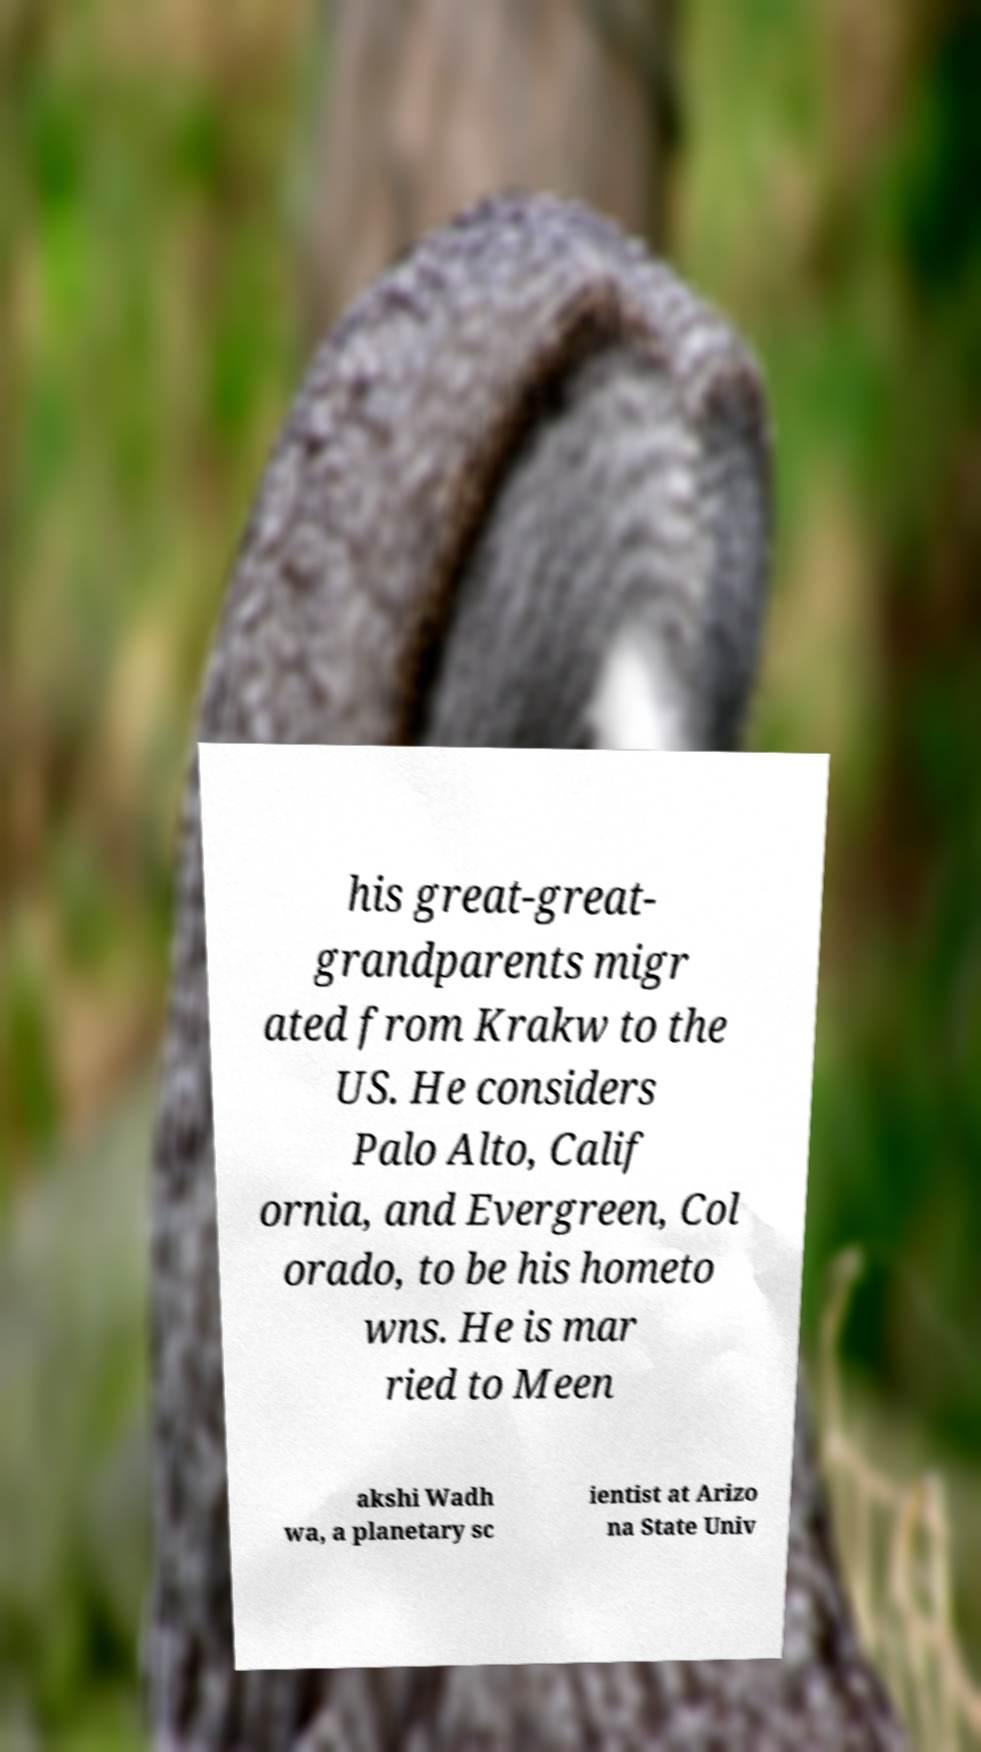Can you read and provide the text displayed in the image?This photo seems to have some interesting text. Can you extract and type it out for me? his great-great- grandparents migr ated from Krakw to the US. He considers Palo Alto, Calif ornia, and Evergreen, Col orado, to be his hometo wns. He is mar ried to Meen akshi Wadh wa, a planetary sc ientist at Arizo na State Univ 